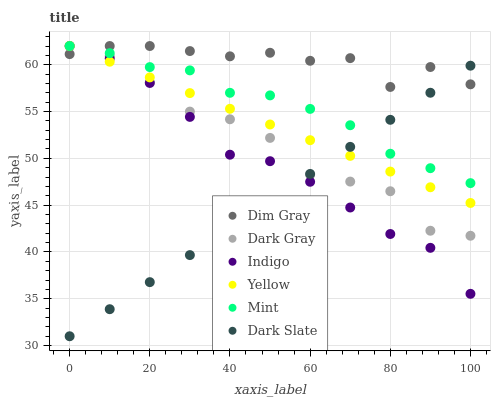Does Dark Slate have the minimum area under the curve?
Answer yes or no. Yes. Does Dim Gray have the maximum area under the curve?
Answer yes or no. Yes. Does Indigo have the minimum area under the curve?
Answer yes or no. No. Does Indigo have the maximum area under the curve?
Answer yes or no. No. Is Yellow the smoothest?
Answer yes or no. Yes. Is Dark Gray the roughest?
Answer yes or no. Yes. Is Indigo the smoothest?
Answer yes or no. No. Is Indigo the roughest?
Answer yes or no. No. Does Dark Slate have the lowest value?
Answer yes or no. Yes. Does Indigo have the lowest value?
Answer yes or no. No. Does Mint have the highest value?
Answer yes or no. Yes. Does Dark Slate have the highest value?
Answer yes or no. No. Does Mint intersect Indigo?
Answer yes or no. Yes. Is Mint less than Indigo?
Answer yes or no. No. Is Mint greater than Indigo?
Answer yes or no. No. 